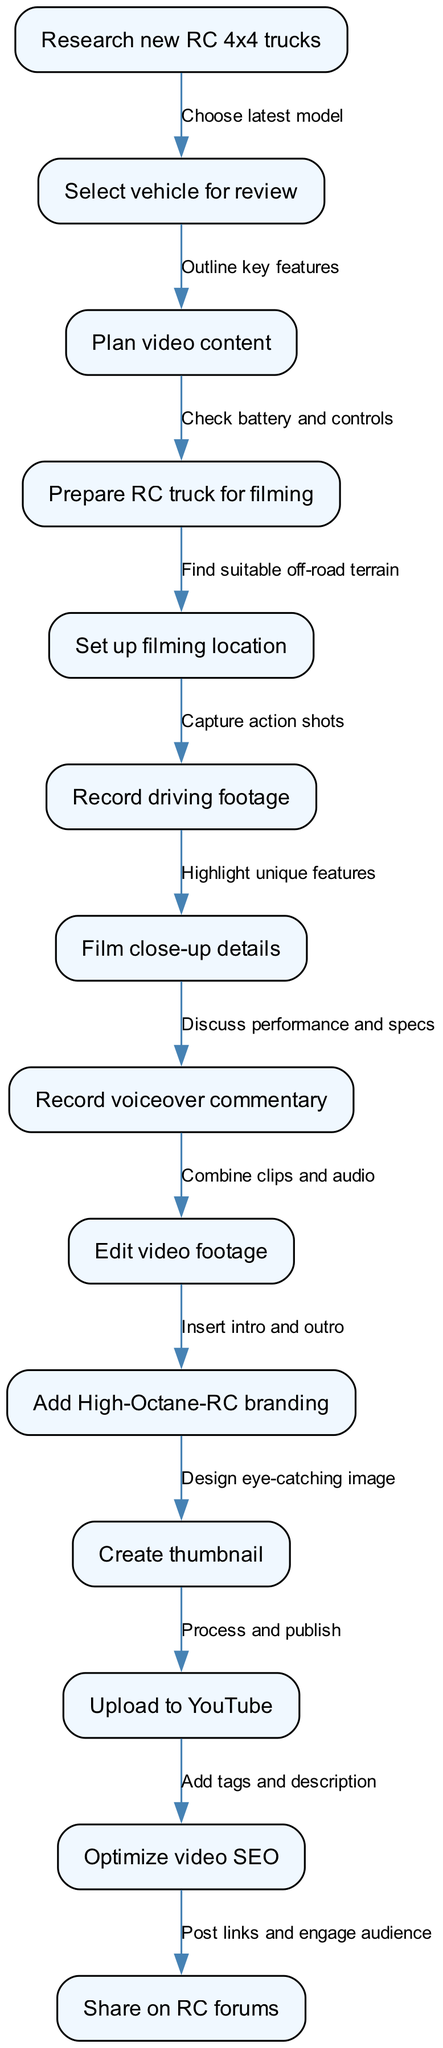What is the first step in the video production process? The first node in the flowchart is "Research new RC 4x4 trucks," indicating this is where the process begins.
Answer: Research new RC 4x4 trucks How many nodes are present in the flowchart? By counting the nodes listed in the diagram, there are 13 steps in the production process.
Answer: 13 What follows after "Plan video content"? The next node that follows "Plan video content" in the flowchart is "Prepare RC truck for filming."
Answer: Prepare RC truck for filming Which two nodes are directly connected by an edge labeled "Capture action shots"? The edge labeled "Capture action shots" connects "Record driving footage" and "Film close-up details." This indicates the relationship between these two nodes.
Answer: Record driving footage and Film close-up details What is the last step before uploading the video to YouTube? Before uploading to YouTube, the flowchart shows "Add High-Octane-RC branding" as the last step before the upload.
Answer: Add High-Octane-RC branding How many edges are there in the diagram? The flowchart has 12 directed edges connecting the 13 nodes, representing the flow of the production process.
Answer: 12 What is the primary action in the node following "Select vehicle for review"? The primary action following "Select vehicle for review" is "Plan video content," indicating a logical next step in preparing the video.
Answer: Plan video content Which node contains the voiceover aspect of the video? The node that includes the voiceover aspect is "Record voiceover commentary," which indicates the introduction of audio.
Answer: Record voiceover commentary What is the final node in the production process? The last node in the flowchart is "Share on RC forums," which represents the last action taken after the video is published.
Answer: Share on RC forums 